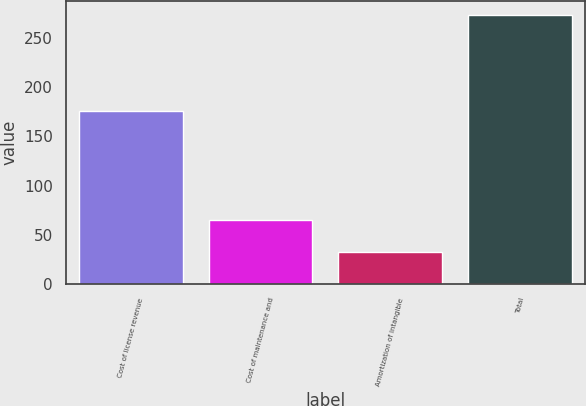Convert chart to OTSL. <chart><loc_0><loc_0><loc_500><loc_500><bar_chart><fcel>Cost of license revenue<fcel>Cost of maintenance and<fcel>Amortization of intangible<fcel>Total<nl><fcel>175.6<fcel>65.4<fcel>32.7<fcel>273.7<nl></chart> 